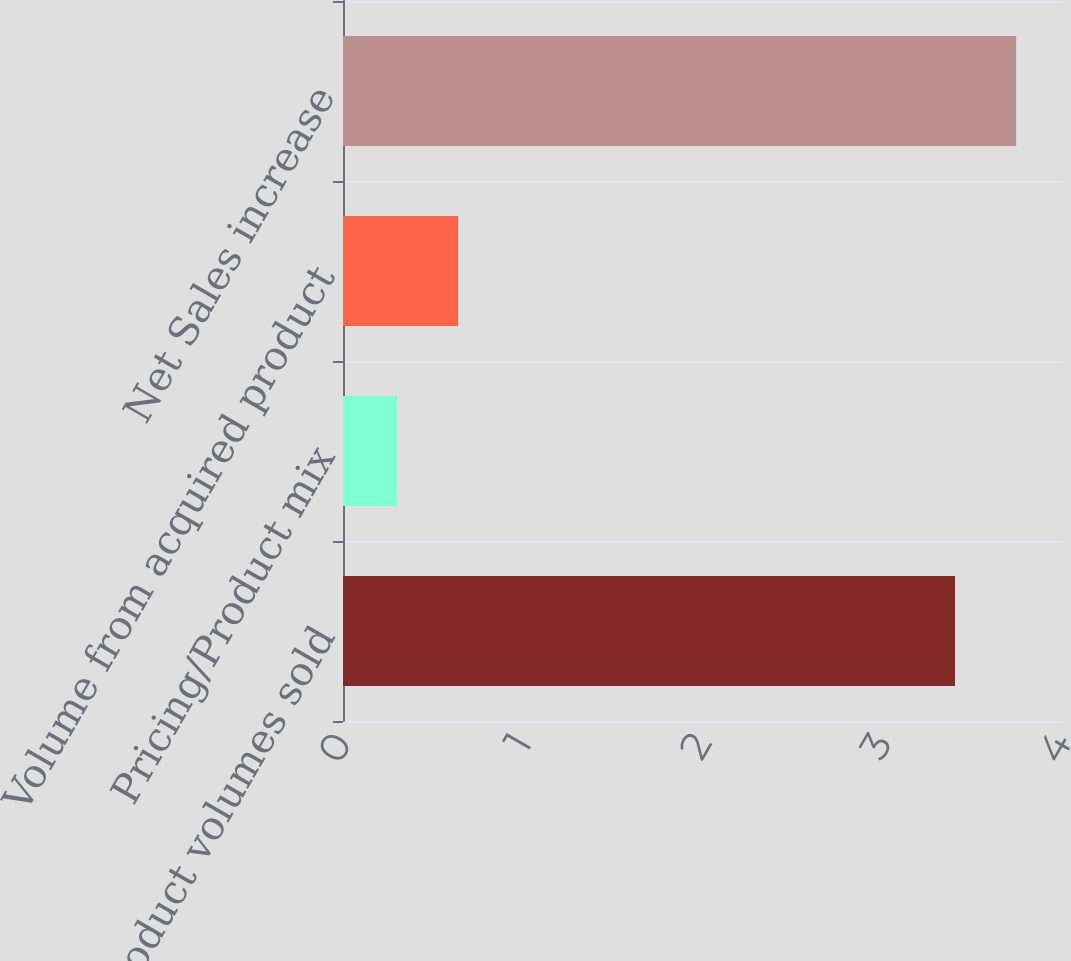Convert chart to OTSL. <chart><loc_0><loc_0><loc_500><loc_500><bar_chart><fcel>Product volumes sold<fcel>Pricing/Product mix<fcel>Volume from acquired product<fcel>Net Sales increase<nl><fcel>3.4<fcel>0.3<fcel>0.64<fcel>3.74<nl></chart> 